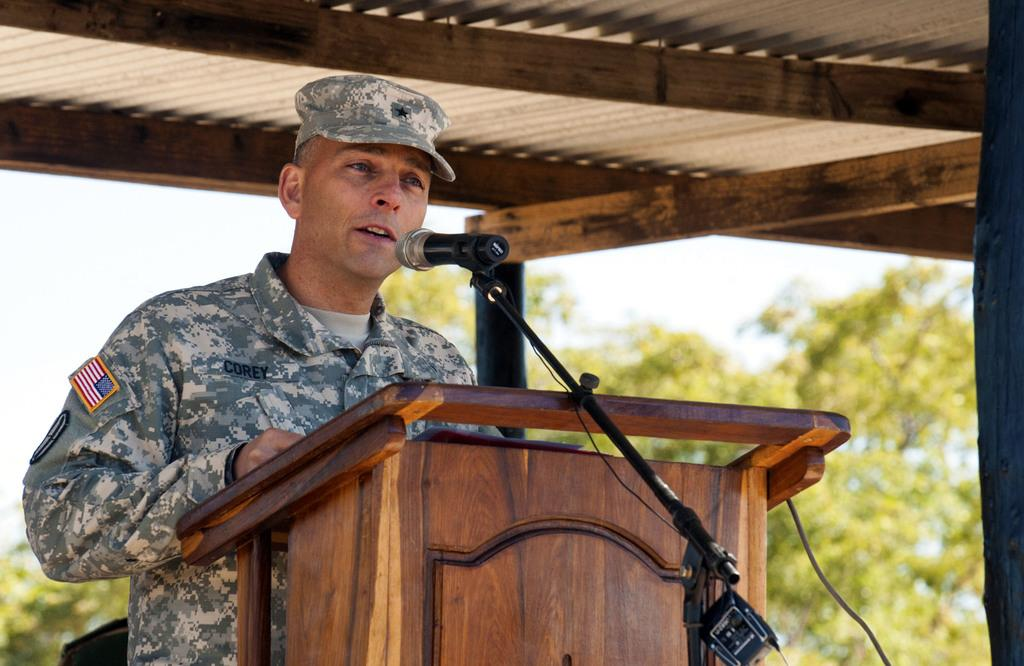Who is the main subject in the image? There is a man in the image. What is the man doing in the image? The man is standing at a podium and speaking with the help of a microphone. What is the man wearing on his head? The man is wearing a cap on his head. What can be seen in the background of the image? There are trees visible in the background of the image. How would you describe the weather in the image? The sky is cloudy in the image. What color is the notebook that the man is holding in the image? There is no notebook present in the image; the man is using a microphone to speak. 